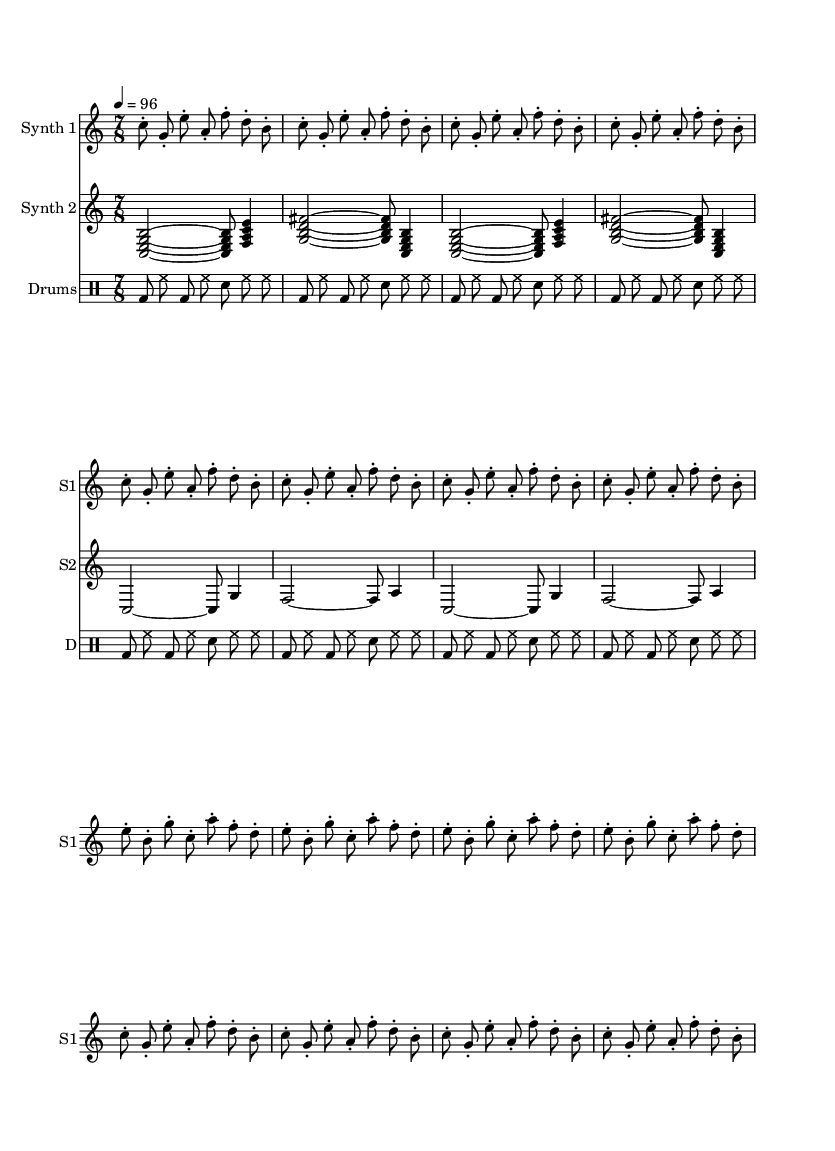What is the time signature of this piece? The time signature is displayed at the beginning of the score as 7/8, indicating there are 7 beats in each measure and the eighth note receives one beat.
Answer: 7/8 What is the tempo marking indicated in the score? The tempo marking at the beginning specifies a tempo of 96 beats per minute, indicating the speed at which the piece should be performed.
Answer: 96 How many repetitions are there of the first pattern in Synth 1? The first pattern in Synth 1 is repeated four times, as indicated by the repeat unfolding notation.
Answer: 4 Which instrument is labeled as "S2"? The instrument "Synth 2" is labeled as "S2" in the staff designation, indicating its shorthand name for reference.
Answer: Synth 2 What is the drum pattern's rhythmic structure? The drum pattern consists of a consistent sequence of bass drum, hi-hat, and snare drum, repeated eight times, showcasing a driving rhythm typical for electronic music.
Answer: bd hh sn What is the range of the first synth's notes, and which is the highest note? The highest note in the first synth's sequence is g', which is the only g note an octave above middle c, demonstrating a varied pitch range within this synth line.
Answer: g' What chord is played in the second measure of Synth 2? The second measure of Synth 2 features a chord made up of the notes c, e, g, and b, which form a C major seventh chord, typical in experimental electronic music for creating harmony.
Answer: C major seventh 